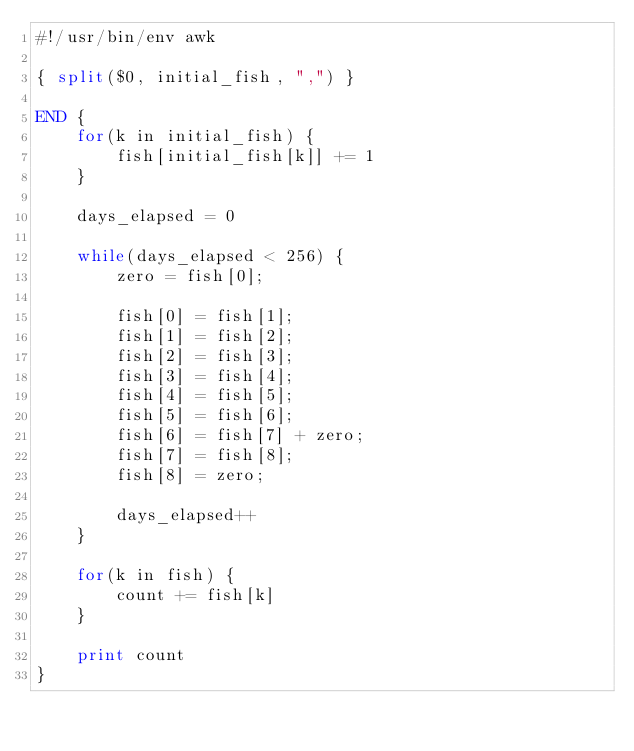Convert code to text. <code><loc_0><loc_0><loc_500><loc_500><_Awk_>#!/usr/bin/env awk

{ split($0, initial_fish, ",") }

END {
    for(k in initial_fish) {
        fish[initial_fish[k]] += 1
    }

    days_elapsed = 0

    while(days_elapsed < 256) {
        zero = fish[0];

        fish[0] = fish[1];
        fish[1] = fish[2];
        fish[2] = fish[3];
        fish[3] = fish[4];
        fish[4] = fish[5];
        fish[5] = fish[6];
        fish[6] = fish[7] + zero;
        fish[7] = fish[8];
        fish[8] = zero;

        days_elapsed++
    }

    for(k in fish) {
        count += fish[k]
    }

    print count
}</code> 